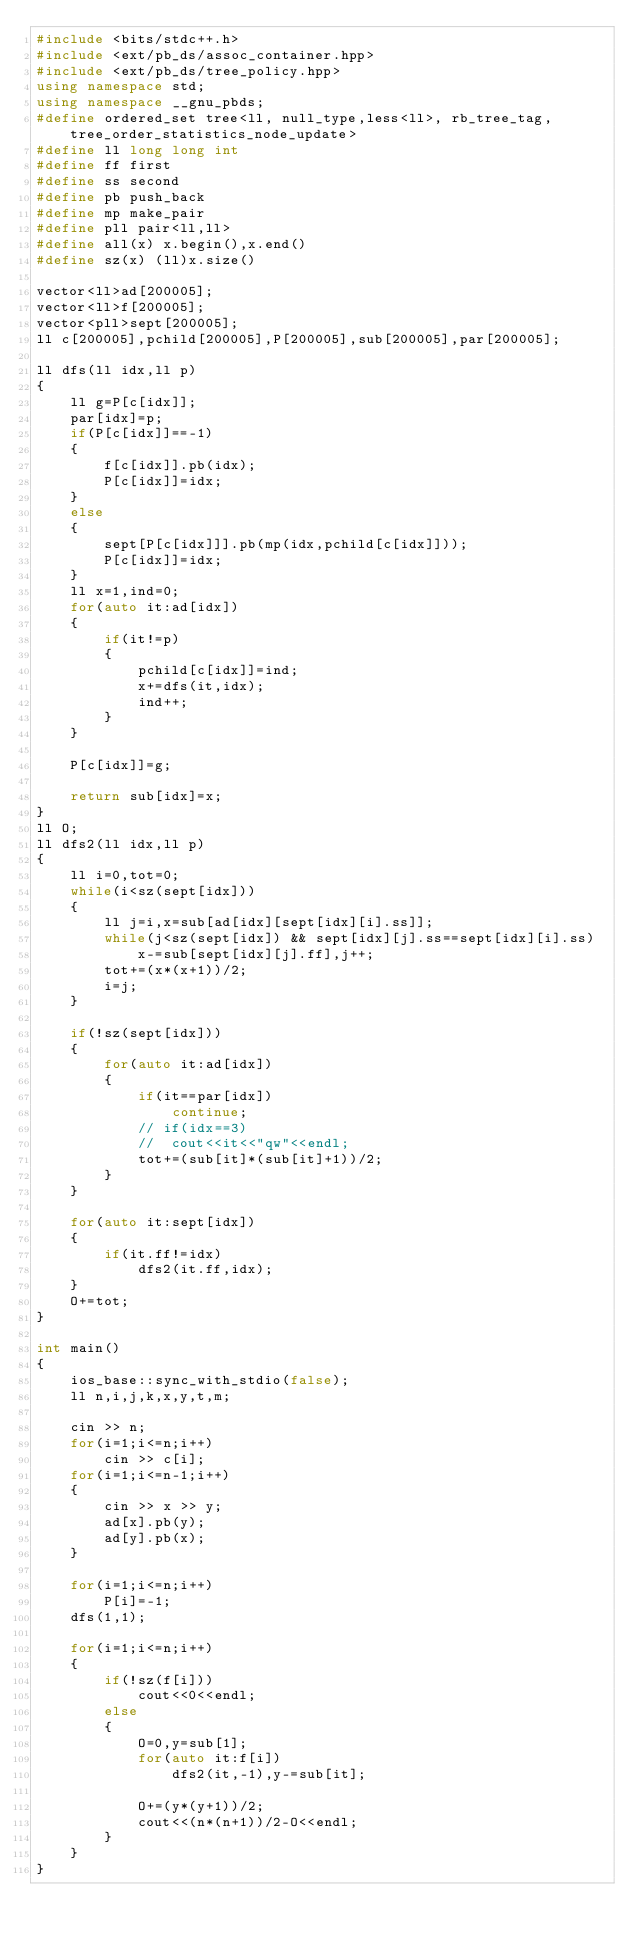<code> <loc_0><loc_0><loc_500><loc_500><_C++_>#include <bits/stdc++.h>
#include <ext/pb_ds/assoc_container.hpp> 
#include <ext/pb_ds/tree_policy.hpp> 
using namespace std;
using namespace __gnu_pbds;   
#define ordered_set tree<ll, null_type,less<ll>, rb_tree_tag,tree_order_statistics_node_update> 
#define ll long long int
#define ff first
#define ss second
#define pb push_back
#define mp make_pair
#define pll pair<ll,ll>
#define all(x) x.begin(),x.end()
#define sz(x) (ll)x.size() 

vector<ll>ad[200005];
vector<ll>f[200005];
vector<pll>sept[200005];
ll c[200005],pchild[200005],P[200005],sub[200005],par[200005];

ll dfs(ll idx,ll p)
{
	ll g=P[c[idx]];
	par[idx]=p;
	if(P[c[idx]]==-1)
	{
		f[c[idx]].pb(idx);
		P[c[idx]]=idx;
	}
	else
	{
		sept[P[c[idx]]].pb(mp(idx,pchild[c[idx]]));
		P[c[idx]]=idx;
	}
	ll x=1,ind=0;
	for(auto it:ad[idx])
	{
		if(it!=p)
		{
			pchild[c[idx]]=ind;
			x+=dfs(it,idx);
			ind++;
		}
	}

	P[c[idx]]=g;

	return sub[idx]=x;
}
ll O;
ll dfs2(ll idx,ll p)
{
	ll i=0,tot=0;
	while(i<sz(sept[idx]))
	{
		ll j=i,x=sub[ad[idx][sept[idx][i].ss]];
		while(j<sz(sept[idx]) && sept[idx][j].ss==sept[idx][i].ss)
			x-=sub[sept[idx][j].ff],j++;
		tot+=(x*(x+1))/2;
		i=j;
	}

	if(!sz(sept[idx]))
	{
		for(auto it:ad[idx])
		{
			if(it==par[idx])
				continue;
			// if(idx==3)
			// 	cout<<it<<"qw"<<endl;
			tot+=(sub[it]*(sub[it]+1))/2;
		}
	}

	for(auto it:sept[idx])
	{
		if(it.ff!=idx)
			dfs2(it.ff,idx);
	}
	O+=tot;
}

int main()
{
    ios_base::sync_with_stdio(false);
	ll n,i,j,k,x,y,t,m;

	cin >> n;
	for(i=1;i<=n;i++)
		cin >> c[i];
	for(i=1;i<=n-1;i++)
	{
		cin >> x >> y;
		ad[x].pb(y);
		ad[y].pb(x);
	}

	for(i=1;i<=n;i++)
		P[i]=-1;
	dfs(1,1);

	for(i=1;i<=n;i++)
	{
		if(!sz(f[i]))
			cout<<0<<endl;
		else
		{
			O=0,y=sub[1];
			for(auto it:f[i])
				dfs2(it,-1),y-=sub[it];
			
			O+=(y*(y+1))/2;
			cout<<(n*(n+1))/2-O<<endl;
		}
	}
}</code> 